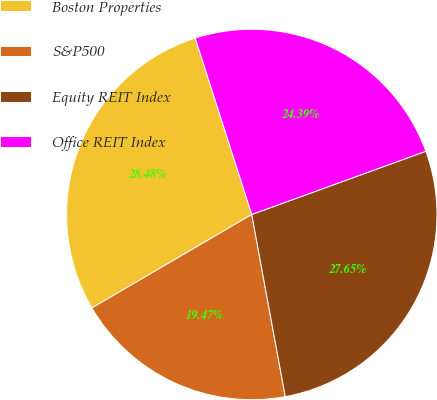<chart> <loc_0><loc_0><loc_500><loc_500><pie_chart><fcel>Boston Properties<fcel>S&P500<fcel>Equity REIT Index<fcel>Office REIT Index<nl><fcel>28.48%<fcel>19.47%<fcel>27.65%<fcel>24.39%<nl></chart> 